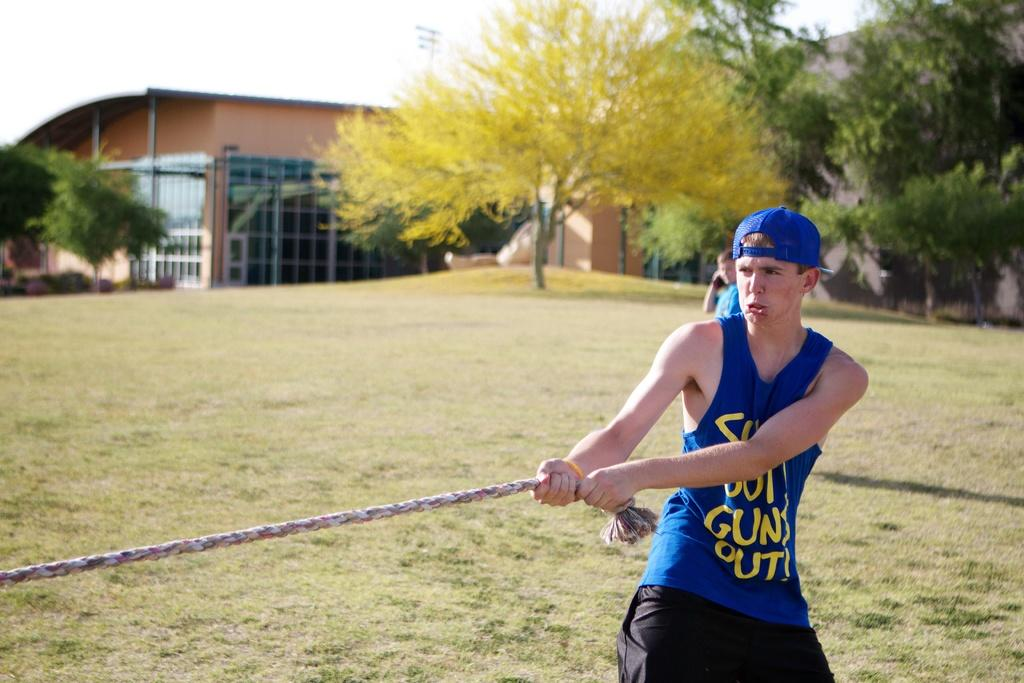<image>
Render a clear and concise summary of the photo. The boy is wearing a blue gun shirt 